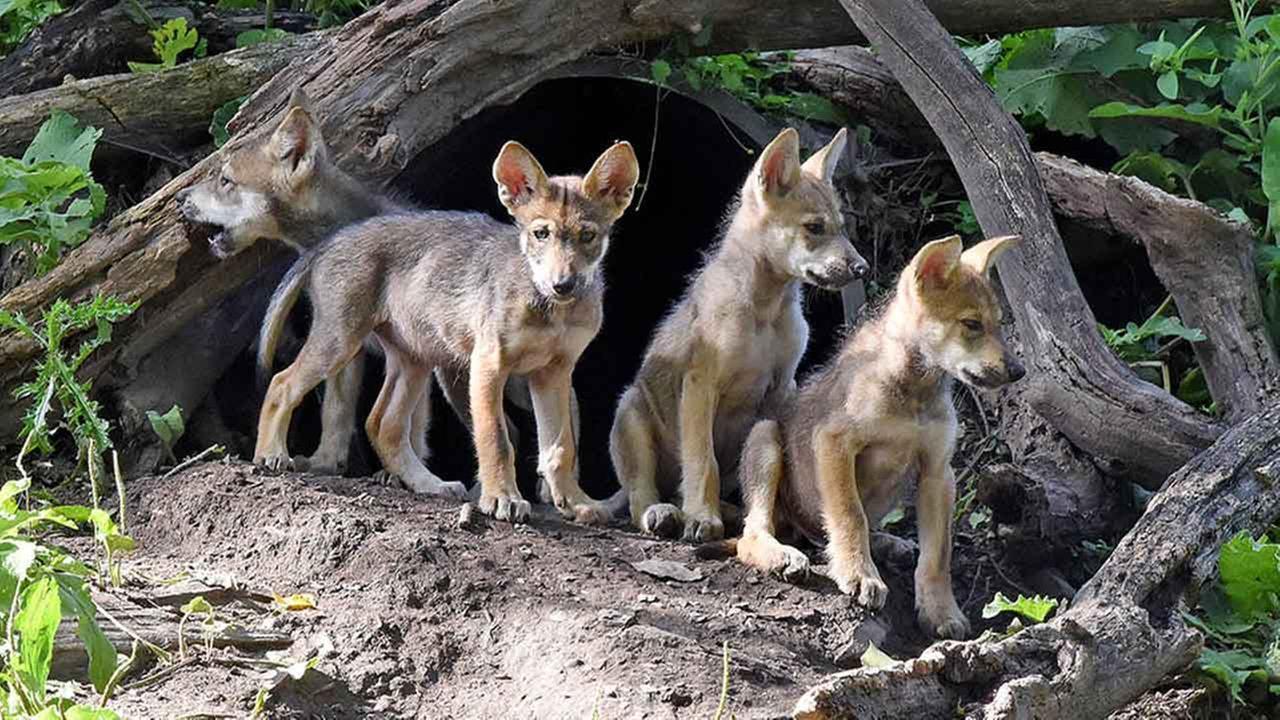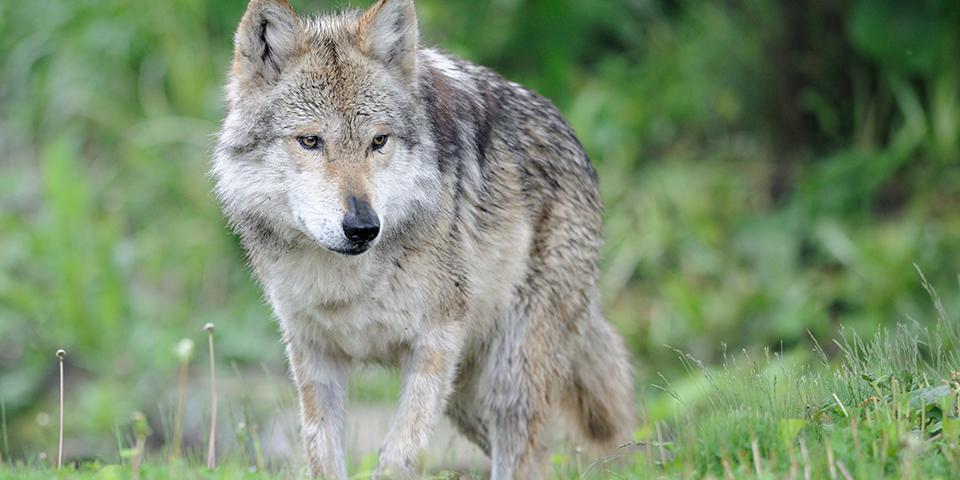The first image is the image on the left, the second image is the image on the right. Evaluate the accuracy of this statement regarding the images: "The animals in the image on the right are in the snow.". Is it true? Answer yes or no. No. The first image is the image on the left, the second image is the image on the right. Evaluate the accuracy of this statement regarding the images: "The right image contains three wolves in the snow.". Is it true? Answer yes or no. No. 